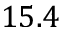<formula> <loc_0><loc_0><loc_500><loc_500>1 5 . 4</formula> 